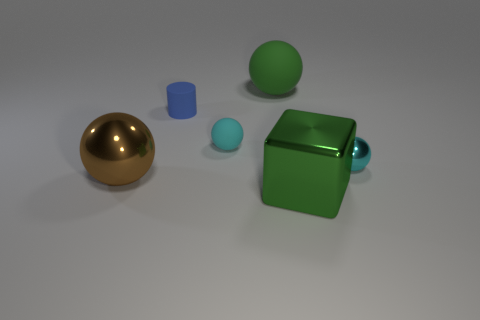There is a large metal object in front of the large brown shiny object; what shape is it?
Provide a short and direct response. Cube. There is a brown thing that is the same size as the green rubber thing; what is it made of?
Offer a very short reply. Metal. How many objects are tiny shiny things that are right of the brown object or large things right of the brown shiny object?
Your response must be concise. 3. There is a cyan ball that is the same material as the blue cylinder; what size is it?
Provide a short and direct response. Small. Is the number of large matte objects the same as the number of big blue rubber cubes?
Provide a succinct answer. No. What number of rubber objects are big gray objects or big brown things?
Make the answer very short. 0. What is the size of the green metal thing?
Offer a terse response. Large. Does the cyan rubber thing have the same size as the blue cylinder?
Offer a very short reply. Yes. What material is the large green thing that is in front of the tiny blue cylinder?
Your response must be concise. Metal. There is a green object that is the same shape as the brown object; what is it made of?
Provide a succinct answer. Rubber. 